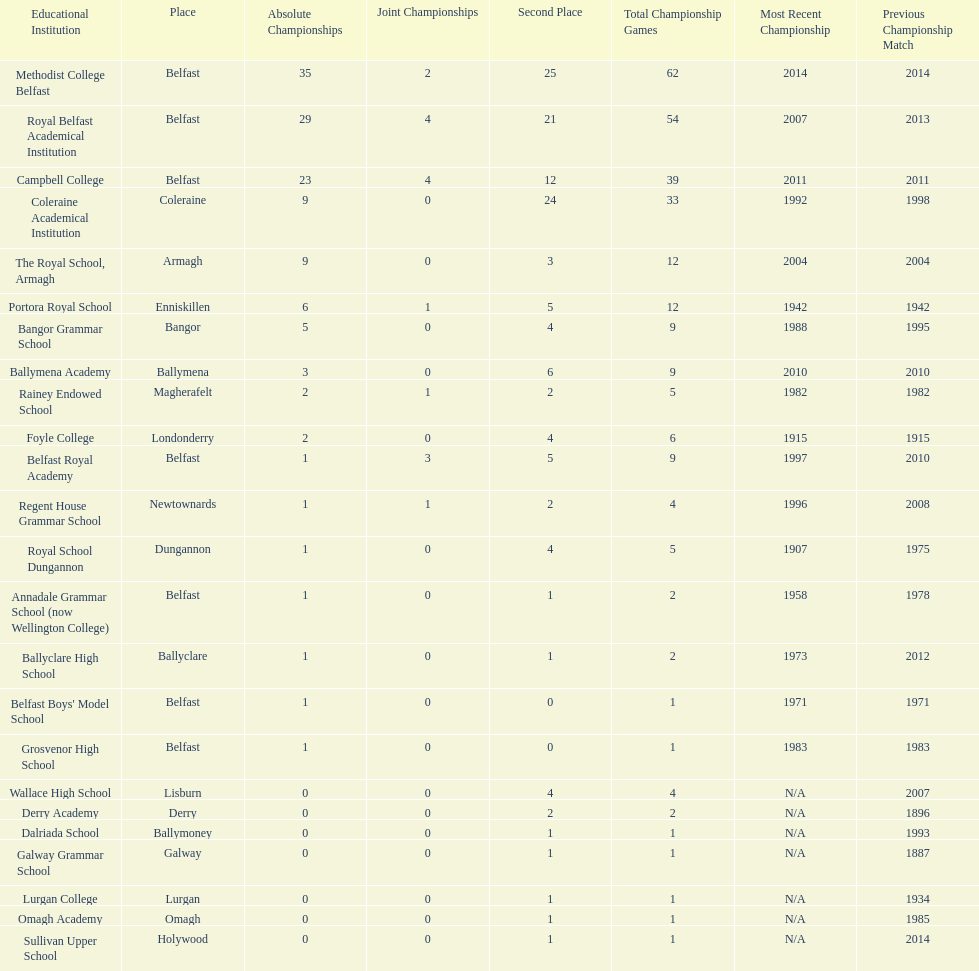What number of total finals does foyle college have? 6. 